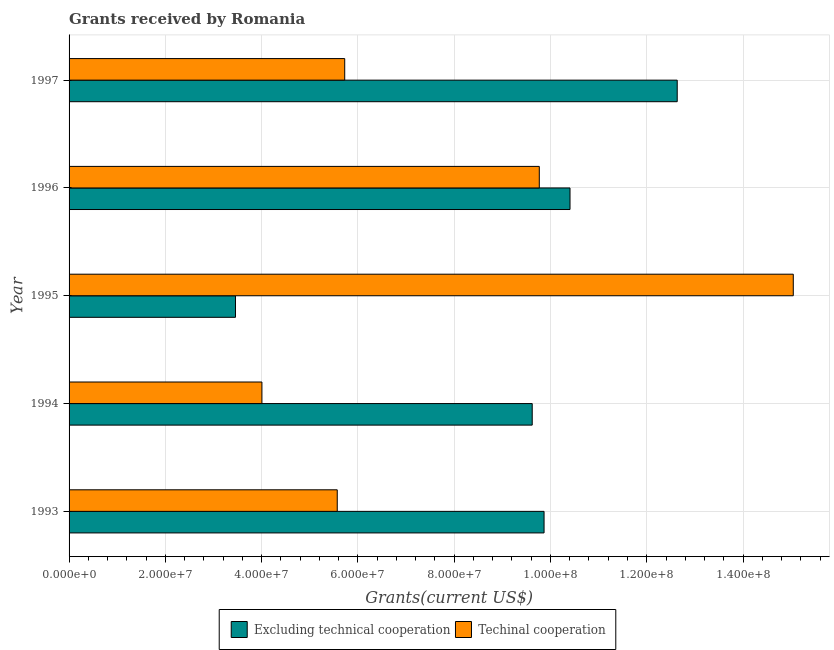How many different coloured bars are there?
Make the answer very short. 2. How many groups of bars are there?
Give a very brief answer. 5. How many bars are there on the 4th tick from the bottom?
Your answer should be compact. 2. What is the label of the 1st group of bars from the top?
Offer a terse response. 1997. What is the amount of grants received(including technical cooperation) in 1995?
Ensure brevity in your answer.  1.50e+08. Across all years, what is the maximum amount of grants received(including technical cooperation)?
Keep it short and to the point. 1.50e+08. Across all years, what is the minimum amount of grants received(excluding technical cooperation)?
Offer a terse response. 3.46e+07. What is the total amount of grants received(excluding technical cooperation) in the graph?
Offer a terse response. 4.60e+08. What is the difference between the amount of grants received(including technical cooperation) in 1995 and that in 1997?
Make the answer very short. 9.32e+07. What is the difference between the amount of grants received(excluding technical cooperation) in 1995 and the amount of grants received(including technical cooperation) in 1994?
Your answer should be very brief. -5.49e+06. What is the average amount of grants received(including technical cooperation) per year?
Your response must be concise. 8.02e+07. In the year 1995, what is the difference between the amount of grants received(including technical cooperation) and amount of grants received(excluding technical cooperation)?
Your response must be concise. 1.16e+08. In how many years, is the amount of grants received(including technical cooperation) greater than 88000000 US$?
Make the answer very short. 2. What is the ratio of the amount of grants received(including technical cooperation) in 1994 to that in 1996?
Your answer should be compact. 0.41. Is the amount of grants received(excluding technical cooperation) in 1996 less than that in 1997?
Provide a succinct answer. Yes. Is the difference between the amount of grants received(including technical cooperation) in 1993 and 1995 greater than the difference between the amount of grants received(excluding technical cooperation) in 1993 and 1995?
Provide a short and direct response. No. What is the difference between the highest and the second highest amount of grants received(including technical cooperation)?
Offer a very short reply. 5.28e+07. What is the difference between the highest and the lowest amount of grants received(including technical cooperation)?
Offer a terse response. 1.10e+08. What does the 1st bar from the top in 1997 represents?
Make the answer very short. Techinal cooperation. What does the 2nd bar from the bottom in 1997 represents?
Ensure brevity in your answer.  Techinal cooperation. How many bars are there?
Your response must be concise. 10. Are all the bars in the graph horizontal?
Ensure brevity in your answer.  Yes. How many years are there in the graph?
Provide a succinct answer. 5. Does the graph contain any zero values?
Offer a very short reply. No. Does the graph contain grids?
Your answer should be very brief. Yes. Where does the legend appear in the graph?
Your response must be concise. Bottom center. How many legend labels are there?
Keep it short and to the point. 2. How are the legend labels stacked?
Your answer should be compact. Horizontal. What is the title of the graph?
Offer a very short reply. Grants received by Romania. Does "Services" appear as one of the legend labels in the graph?
Your response must be concise. No. What is the label or title of the X-axis?
Your answer should be compact. Grants(current US$). What is the Grants(current US$) in Excluding technical cooperation in 1993?
Offer a very short reply. 9.87e+07. What is the Grants(current US$) in Techinal cooperation in 1993?
Give a very brief answer. 5.57e+07. What is the Grants(current US$) of Excluding technical cooperation in 1994?
Your answer should be very brief. 9.62e+07. What is the Grants(current US$) in Techinal cooperation in 1994?
Ensure brevity in your answer.  4.01e+07. What is the Grants(current US$) of Excluding technical cooperation in 1995?
Make the answer very short. 3.46e+07. What is the Grants(current US$) in Techinal cooperation in 1995?
Your answer should be very brief. 1.50e+08. What is the Grants(current US$) in Excluding technical cooperation in 1996?
Your answer should be very brief. 1.04e+08. What is the Grants(current US$) of Techinal cooperation in 1996?
Your answer should be compact. 9.77e+07. What is the Grants(current US$) of Excluding technical cooperation in 1997?
Your answer should be compact. 1.26e+08. What is the Grants(current US$) of Techinal cooperation in 1997?
Offer a very short reply. 5.73e+07. Across all years, what is the maximum Grants(current US$) of Excluding technical cooperation?
Your answer should be very brief. 1.26e+08. Across all years, what is the maximum Grants(current US$) in Techinal cooperation?
Your answer should be very brief. 1.50e+08. Across all years, what is the minimum Grants(current US$) of Excluding technical cooperation?
Ensure brevity in your answer.  3.46e+07. Across all years, what is the minimum Grants(current US$) in Techinal cooperation?
Provide a succinct answer. 4.01e+07. What is the total Grants(current US$) in Excluding technical cooperation in the graph?
Provide a short and direct response. 4.60e+08. What is the total Grants(current US$) in Techinal cooperation in the graph?
Keep it short and to the point. 4.01e+08. What is the difference between the Grants(current US$) in Excluding technical cooperation in 1993 and that in 1994?
Make the answer very short. 2.46e+06. What is the difference between the Grants(current US$) of Techinal cooperation in 1993 and that in 1994?
Provide a short and direct response. 1.56e+07. What is the difference between the Grants(current US$) of Excluding technical cooperation in 1993 and that in 1995?
Offer a terse response. 6.41e+07. What is the difference between the Grants(current US$) of Techinal cooperation in 1993 and that in 1995?
Offer a terse response. -9.47e+07. What is the difference between the Grants(current US$) of Excluding technical cooperation in 1993 and that in 1996?
Provide a succinct answer. -5.39e+06. What is the difference between the Grants(current US$) in Techinal cooperation in 1993 and that in 1996?
Give a very brief answer. -4.20e+07. What is the difference between the Grants(current US$) of Excluding technical cooperation in 1993 and that in 1997?
Provide a succinct answer. -2.77e+07. What is the difference between the Grants(current US$) of Techinal cooperation in 1993 and that in 1997?
Offer a terse response. -1.55e+06. What is the difference between the Grants(current US$) in Excluding technical cooperation in 1994 and that in 1995?
Your answer should be very brief. 6.16e+07. What is the difference between the Grants(current US$) in Techinal cooperation in 1994 and that in 1995?
Offer a terse response. -1.10e+08. What is the difference between the Grants(current US$) in Excluding technical cooperation in 1994 and that in 1996?
Your answer should be very brief. -7.85e+06. What is the difference between the Grants(current US$) in Techinal cooperation in 1994 and that in 1996?
Provide a short and direct response. -5.76e+07. What is the difference between the Grants(current US$) of Excluding technical cooperation in 1994 and that in 1997?
Ensure brevity in your answer.  -3.01e+07. What is the difference between the Grants(current US$) of Techinal cooperation in 1994 and that in 1997?
Your response must be concise. -1.72e+07. What is the difference between the Grants(current US$) in Excluding technical cooperation in 1995 and that in 1996?
Your answer should be compact. -6.95e+07. What is the difference between the Grants(current US$) in Techinal cooperation in 1995 and that in 1996?
Ensure brevity in your answer.  5.28e+07. What is the difference between the Grants(current US$) in Excluding technical cooperation in 1995 and that in 1997?
Provide a succinct answer. -9.18e+07. What is the difference between the Grants(current US$) in Techinal cooperation in 1995 and that in 1997?
Offer a terse response. 9.32e+07. What is the difference between the Grants(current US$) of Excluding technical cooperation in 1996 and that in 1997?
Give a very brief answer. -2.23e+07. What is the difference between the Grants(current US$) in Techinal cooperation in 1996 and that in 1997?
Your answer should be very brief. 4.04e+07. What is the difference between the Grants(current US$) of Excluding technical cooperation in 1993 and the Grants(current US$) of Techinal cooperation in 1994?
Ensure brevity in your answer.  5.86e+07. What is the difference between the Grants(current US$) in Excluding technical cooperation in 1993 and the Grants(current US$) in Techinal cooperation in 1995?
Offer a terse response. -5.18e+07. What is the difference between the Grants(current US$) in Excluding technical cooperation in 1993 and the Grants(current US$) in Techinal cooperation in 1996?
Make the answer very short. 9.90e+05. What is the difference between the Grants(current US$) of Excluding technical cooperation in 1993 and the Grants(current US$) of Techinal cooperation in 1997?
Provide a short and direct response. 4.14e+07. What is the difference between the Grants(current US$) in Excluding technical cooperation in 1994 and the Grants(current US$) in Techinal cooperation in 1995?
Your answer should be compact. -5.42e+07. What is the difference between the Grants(current US$) in Excluding technical cooperation in 1994 and the Grants(current US$) in Techinal cooperation in 1996?
Provide a short and direct response. -1.47e+06. What is the difference between the Grants(current US$) of Excluding technical cooperation in 1994 and the Grants(current US$) of Techinal cooperation in 1997?
Provide a short and direct response. 3.90e+07. What is the difference between the Grants(current US$) of Excluding technical cooperation in 1995 and the Grants(current US$) of Techinal cooperation in 1996?
Offer a very short reply. -6.31e+07. What is the difference between the Grants(current US$) of Excluding technical cooperation in 1995 and the Grants(current US$) of Techinal cooperation in 1997?
Offer a very short reply. -2.27e+07. What is the difference between the Grants(current US$) in Excluding technical cooperation in 1996 and the Grants(current US$) in Techinal cooperation in 1997?
Offer a terse response. 4.68e+07. What is the average Grants(current US$) in Excluding technical cooperation per year?
Your answer should be compact. 9.20e+07. What is the average Grants(current US$) of Techinal cooperation per year?
Make the answer very short. 8.02e+07. In the year 1993, what is the difference between the Grants(current US$) of Excluding technical cooperation and Grants(current US$) of Techinal cooperation?
Offer a very short reply. 4.30e+07. In the year 1994, what is the difference between the Grants(current US$) in Excluding technical cooperation and Grants(current US$) in Techinal cooperation?
Your answer should be compact. 5.62e+07. In the year 1995, what is the difference between the Grants(current US$) in Excluding technical cooperation and Grants(current US$) in Techinal cooperation?
Make the answer very short. -1.16e+08. In the year 1996, what is the difference between the Grants(current US$) of Excluding technical cooperation and Grants(current US$) of Techinal cooperation?
Your response must be concise. 6.38e+06. In the year 1997, what is the difference between the Grants(current US$) of Excluding technical cooperation and Grants(current US$) of Techinal cooperation?
Offer a very short reply. 6.91e+07. What is the ratio of the Grants(current US$) of Excluding technical cooperation in 1993 to that in 1994?
Make the answer very short. 1.03. What is the ratio of the Grants(current US$) in Techinal cooperation in 1993 to that in 1994?
Keep it short and to the point. 1.39. What is the ratio of the Grants(current US$) in Excluding technical cooperation in 1993 to that in 1995?
Offer a very short reply. 2.85. What is the ratio of the Grants(current US$) in Techinal cooperation in 1993 to that in 1995?
Your answer should be compact. 0.37. What is the ratio of the Grants(current US$) in Excluding technical cooperation in 1993 to that in 1996?
Your response must be concise. 0.95. What is the ratio of the Grants(current US$) in Techinal cooperation in 1993 to that in 1996?
Provide a short and direct response. 0.57. What is the ratio of the Grants(current US$) in Excluding technical cooperation in 1993 to that in 1997?
Give a very brief answer. 0.78. What is the ratio of the Grants(current US$) of Techinal cooperation in 1993 to that in 1997?
Offer a terse response. 0.97. What is the ratio of the Grants(current US$) in Excluding technical cooperation in 1994 to that in 1995?
Provide a short and direct response. 2.78. What is the ratio of the Grants(current US$) of Techinal cooperation in 1994 to that in 1995?
Your answer should be very brief. 0.27. What is the ratio of the Grants(current US$) in Excluding technical cooperation in 1994 to that in 1996?
Ensure brevity in your answer.  0.92. What is the ratio of the Grants(current US$) of Techinal cooperation in 1994 to that in 1996?
Your answer should be compact. 0.41. What is the ratio of the Grants(current US$) in Excluding technical cooperation in 1994 to that in 1997?
Offer a very short reply. 0.76. What is the ratio of the Grants(current US$) in Techinal cooperation in 1994 to that in 1997?
Provide a short and direct response. 0.7. What is the ratio of the Grants(current US$) of Excluding technical cooperation in 1995 to that in 1996?
Provide a succinct answer. 0.33. What is the ratio of the Grants(current US$) of Techinal cooperation in 1995 to that in 1996?
Offer a terse response. 1.54. What is the ratio of the Grants(current US$) in Excluding technical cooperation in 1995 to that in 1997?
Your answer should be compact. 0.27. What is the ratio of the Grants(current US$) of Techinal cooperation in 1995 to that in 1997?
Make the answer very short. 2.63. What is the ratio of the Grants(current US$) of Excluding technical cooperation in 1996 to that in 1997?
Provide a short and direct response. 0.82. What is the ratio of the Grants(current US$) in Techinal cooperation in 1996 to that in 1997?
Your answer should be compact. 1.71. What is the difference between the highest and the second highest Grants(current US$) of Excluding technical cooperation?
Ensure brevity in your answer.  2.23e+07. What is the difference between the highest and the second highest Grants(current US$) of Techinal cooperation?
Make the answer very short. 5.28e+07. What is the difference between the highest and the lowest Grants(current US$) in Excluding technical cooperation?
Offer a very short reply. 9.18e+07. What is the difference between the highest and the lowest Grants(current US$) of Techinal cooperation?
Offer a very short reply. 1.10e+08. 